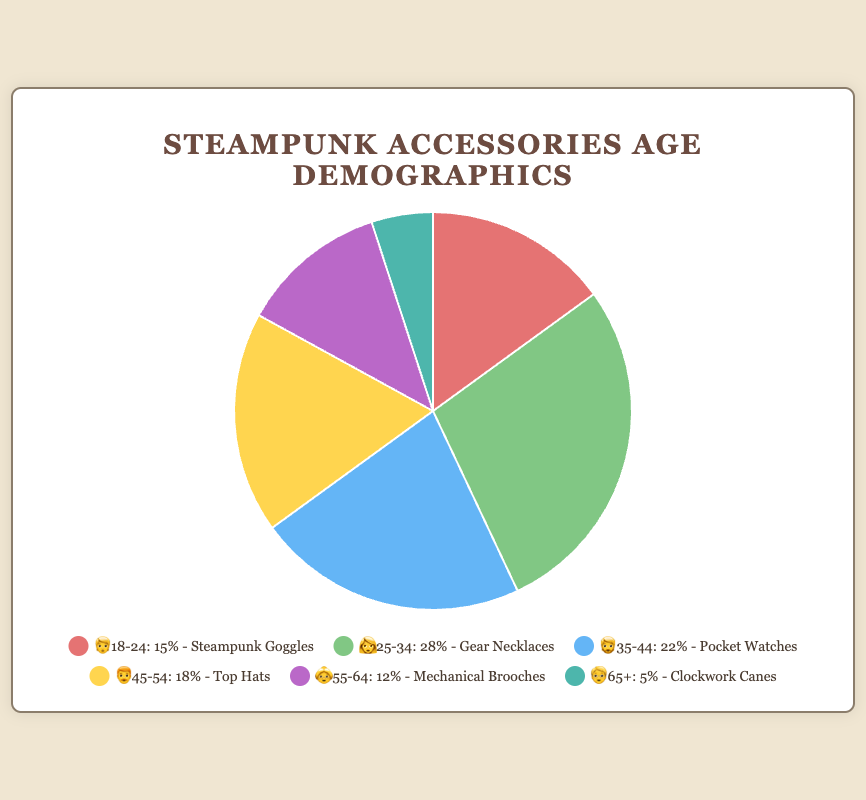which age group has the highest percentage of customers? By looking at the pie chart and the percentages, the age group with the highest percentage is clearly marked.
Answer: 25-34 which steampunk accessory is most popular among customers aged 35-44? According to the pie chart legend, the popular item associated with this age group is specified.
Answer: Pocket Watches what is the total percentage of customers aged 45 and above? Sum the percentages of the age groups 45-54, 55-64, and 65+. These values are 18%, 12%, and 5%. Summing them gives 18 + 12 + 5 = 35.
Answer: 35% how does the percentage of customers aged 25-34 compare with those aged 18-24? Compare the percentages of the specified age groups; 28% for 25-34 and 15% for 18-24.
Answer: 25-34 has a higher percentage which age group prefers Steampunk Goggles? Look at the legend or chart where popular items are listed next to each age group.
Answer: 18-24 is the percentage of customers aged 55-64 greater or less than those aged 45-54? Compare the percentages of the two specified age groups; 12% for 55-64 and 18% for 45-54.
Answer: less what proportion of the customer base is aged under 35? Sum the percentages of the age groups 18-24 and 25-34. These values are 15% and 28%. Summing them gives 15 + 28 = 43.
Answer: 43% what is the second most popular accessory among middle-aged customers (35-54)? Identify the popular items for customers aged 35-44 and 45-54, then note the popularity, Pocket Watches and Top Hats respectively; compare by combining the proportions.
Answer: Top Hats which emblem represents the data point with the lowest percentage? Look at the pie chart and legend for the category with the smallest proportion and its associated emoji.
Answer: 🧓 what accessory is most favored by the least represented age group? The least represented age group is the one with the lowest percentage, which is 65+, and their popular item is noted.
Answer: Clockwork Canes 